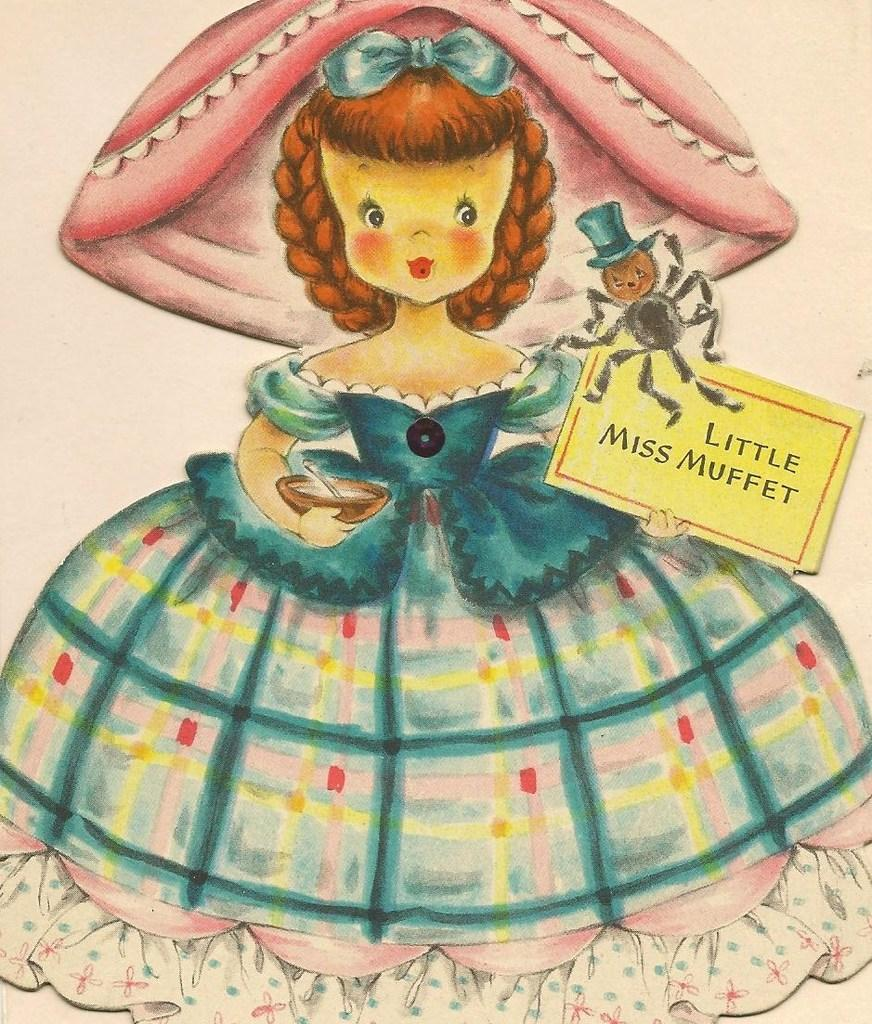What is depicted in the painting in the image? There is a painting of a doll in the image. What other character can be seen in the image? There is a spider with a hat in the image. What type of object with writing is present in the image? There is a paper with text on it in the image. How many women are holding umbrellas in the image? There are no women or umbrellas present in the image. 